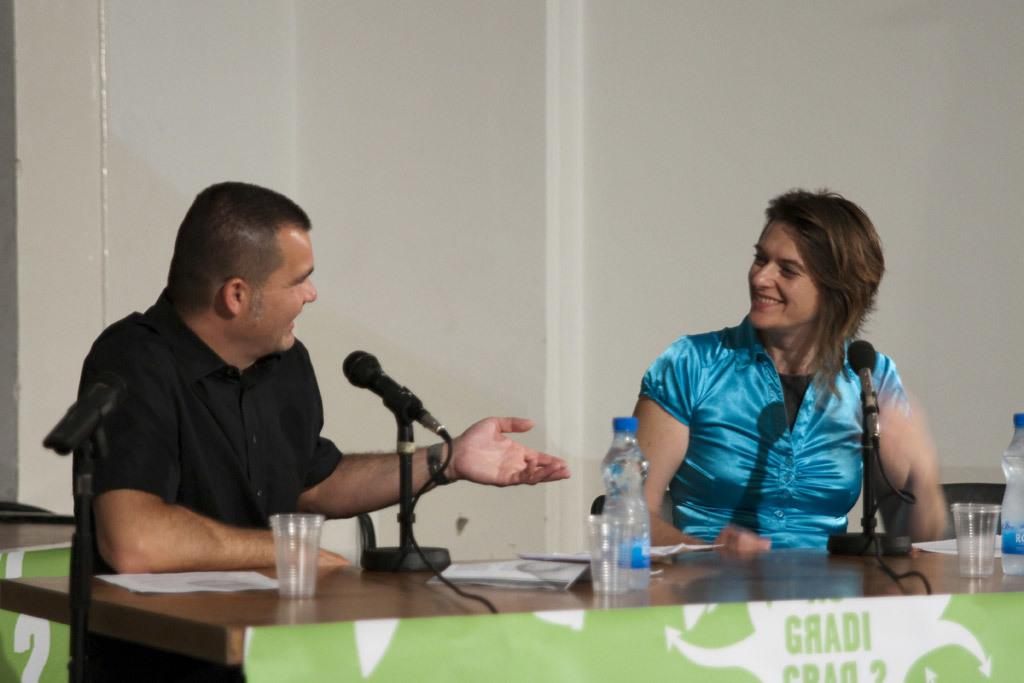What can be seen in the background of the image? There is a wall in the image. How many people are present in the image? There are two persons in the image. What are the two persons doing? The two persons are sitting in front of a table and talking. What are the two persons sitting on? The two persons are sitting on chairs. What is present on the table? There are mikes, water glasses, and bottles on the table. What is the facial expression of the two persons? The two persons are smiling. Can you see any dirt on the floor in the image? There is no mention of dirt or the floor in the provided facts, so it cannot be determined from the image. What type of bead is being used as a decoration in the image? There is no mention of beads or decorations in the provided facts, so it cannot be determined from the image. 